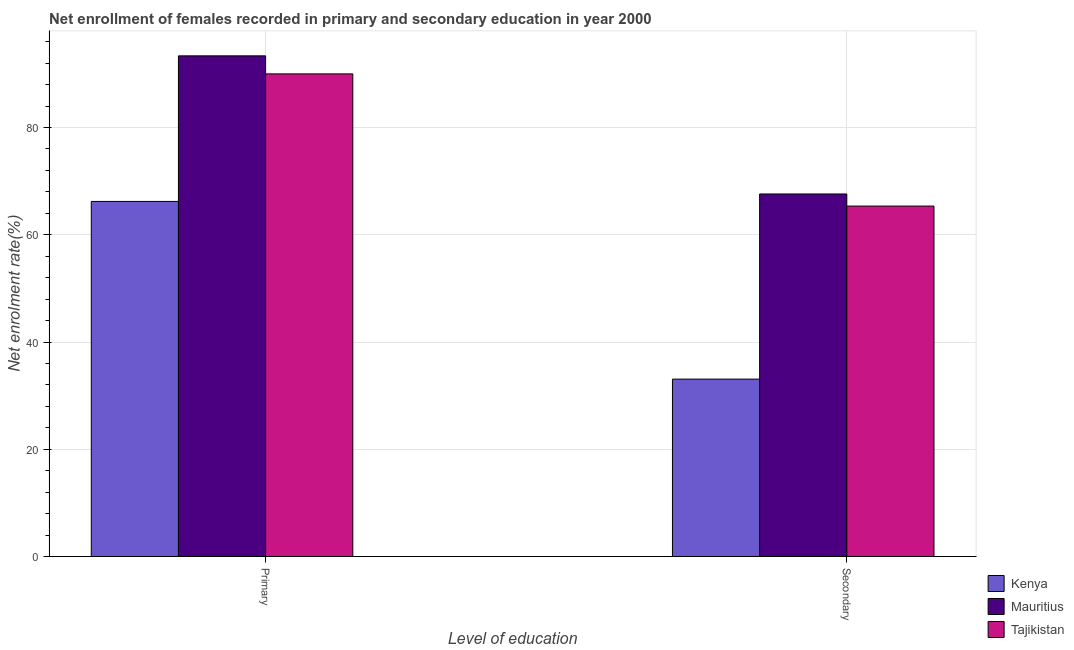How many groups of bars are there?
Keep it short and to the point. 2. Are the number of bars on each tick of the X-axis equal?
Offer a very short reply. Yes. What is the label of the 1st group of bars from the left?
Your answer should be very brief. Primary. What is the enrollment rate in secondary education in Kenya?
Keep it short and to the point. 33.08. Across all countries, what is the maximum enrollment rate in primary education?
Your response must be concise. 93.36. Across all countries, what is the minimum enrollment rate in primary education?
Your answer should be compact. 66.22. In which country was the enrollment rate in primary education maximum?
Ensure brevity in your answer.  Mauritius. In which country was the enrollment rate in secondary education minimum?
Your answer should be very brief. Kenya. What is the total enrollment rate in primary education in the graph?
Offer a very short reply. 249.58. What is the difference between the enrollment rate in secondary education in Tajikistan and that in Mauritius?
Give a very brief answer. -2.25. What is the difference between the enrollment rate in primary education in Mauritius and the enrollment rate in secondary education in Kenya?
Keep it short and to the point. 60.28. What is the average enrollment rate in primary education per country?
Keep it short and to the point. 83.19. What is the difference between the enrollment rate in secondary education and enrollment rate in primary education in Mauritius?
Ensure brevity in your answer.  -25.76. What is the ratio of the enrollment rate in secondary education in Tajikistan to that in Mauritius?
Offer a terse response. 0.97. Is the enrollment rate in secondary education in Tajikistan less than that in Kenya?
Offer a terse response. No. In how many countries, is the enrollment rate in primary education greater than the average enrollment rate in primary education taken over all countries?
Offer a terse response. 2. What does the 3rd bar from the left in Primary represents?
Make the answer very short. Tajikistan. What does the 2nd bar from the right in Primary represents?
Make the answer very short. Mauritius. How many bars are there?
Your answer should be compact. 6. Are all the bars in the graph horizontal?
Your answer should be compact. No. How many countries are there in the graph?
Provide a succinct answer. 3. Are the values on the major ticks of Y-axis written in scientific E-notation?
Provide a succinct answer. No. Does the graph contain any zero values?
Your response must be concise. No. How are the legend labels stacked?
Make the answer very short. Vertical. What is the title of the graph?
Make the answer very short. Net enrollment of females recorded in primary and secondary education in year 2000. What is the label or title of the X-axis?
Give a very brief answer. Level of education. What is the label or title of the Y-axis?
Your answer should be compact. Net enrolment rate(%). What is the Net enrolment rate(%) in Kenya in Primary?
Your response must be concise. 66.22. What is the Net enrolment rate(%) in Mauritius in Primary?
Keep it short and to the point. 93.36. What is the Net enrolment rate(%) in Tajikistan in Primary?
Your response must be concise. 90. What is the Net enrolment rate(%) of Kenya in Secondary?
Give a very brief answer. 33.08. What is the Net enrolment rate(%) of Mauritius in Secondary?
Provide a short and direct response. 67.61. What is the Net enrolment rate(%) of Tajikistan in Secondary?
Offer a very short reply. 65.36. Across all Level of education, what is the maximum Net enrolment rate(%) of Kenya?
Provide a short and direct response. 66.22. Across all Level of education, what is the maximum Net enrolment rate(%) in Mauritius?
Offer a very short reply. 93.36. Across all Level of education, what is the maximum Net enrolment rate(%) of Tajikistan?
Your answer should be very brief. 90. Across all Level of education, what is the minimum Net enrolment rate(%) in Kenya?
Offer a terse response. 33.08. Across all Level of education, what is the minimum Net enrolment rate(%) of Mauritius?
Your answer should be compact. 67.61. Across all Level of education, what is the minimum Net enrolment rate(%) in Tajikistan?
Your response must be concise. 65.36. What is the total Net enrolment rate(%) of Kenya in the graph?
Offer a terse response. 99.3. What is the total Net enrolment rate(%) of Mauritius in the graph?
Your response must be concise. 160.97. What is the total Net enrolment rate(%) of Tajikistan in the graph?
Your response must be concise. 155.36. What is the difference between the Net enrolment rate(%) of Kenya in Primary and that in Secondary?
Keep it short and to the point. 33.13. What is the difference between the Net enrolment rate(%) in Mauritius in Primary and that in Secondary?
Your answer should be very brief. 25.76. What is the difference between the Net enrolment rate(%) of Tajikistan in Primary and that in Secondary?
Give a very brief answer. 24.65. What is the difference between the Net enrolment rate(%) in Kenya in Primary and the Net enrolment rate(%) in Mauritius in Secondary?
Make the answer very short. -1.39. What is the difference between the Net enrolment rate(%) of Kenya in Primary and the Net enrolment rate(%) of Tajikistan in Secondary?
Offer a terse response. 0.86. What is the difference between the Net enrolment rate(%) of Mauritius in Primary and the Net enrolment rate(%) of Tajikistan in Secondary?
Your answer should be very brief. 28.01. What is the average Net enrolment rate(%) of Kenya per Level of education?
Give a very brief answer. 49.65. What is the average Net enrolment rate(%) in Mauritius per Level of education?
Your answer should be compact. 80.49. What is the average Net enrolment rate(%) in Tajikistan per Level of education?
Provide a short and direct response. 77.68. What is the difference between the Net enrolment rate(%) in Kenya and Net enrolment rate(%) in Mauritius in Primary?
Make the answer very short. -27.15. What is the difference between the Net enrolment rate(%) in Kenya and Net enrolment rate(%) in Tajikistan in Primary?
Keep it short and to the point. -23.78. What is the difference between the Net enrolment rate(%) of Mauritius and Net enrolment rate(%) of Tajikistan in Primary?
Keep it short and to the point. 3.36. What is the difference between the Net enrolment rate(%) in Kenya and Net enrolment rate(%) in Mauritius in Secondary?
Offer a very short reply. -34.53. What is the difference between the Net enrolment rate(%) of Kenya and Net enrolment rate(%) of Tajikistan in Secondary?
Ensure brevity in your answer.  -32.27. What is the difference between the Net enrolment rate(%) of Mauritius and Net enrolment rate(%) of Tajikistan in Secondary?
Offer a terse response. 2.25. What is the ratio of the Net enrolment rate(%) of Kenya in Primary to that in Secondary?
Offer a terse response. 2. What is the ratio of the Net enrolment rate(%) in Mauritius in Primary to that in Secondary?
Your answer should be very brief. 1.38. What is the ratio of the Net enrolment rate(%) in Tajikistan in Primary to that in Secondary?
Your response must be concise. 1.38. What is the difference between the highest and the second highest Net enrolment rate(%) in Kenya?
Give a very brief answer. 33.13. What is the difference between the highest and the second highest Net enrolment rate(%) in Mauritius?
Ensure brevity in your answer.  25.76. What is the difference between the highest and the second highest Net enrolment rate(%) in Tajikistan?
Your response must be concise. 24.65. What is the difference between the highest and the lowest Net enrolment rate(%) of Kenya?
Provide a succinct answer. 33.13. What is the difference between the highest and the lowest Net enrolment rate(%) in Mauritius?
Provide a short and direct response. 25.76. What is the difference between the highest and the lowest Net enrolment rate(%) in Tajikistan?
Offer a terse response. 24.65. 